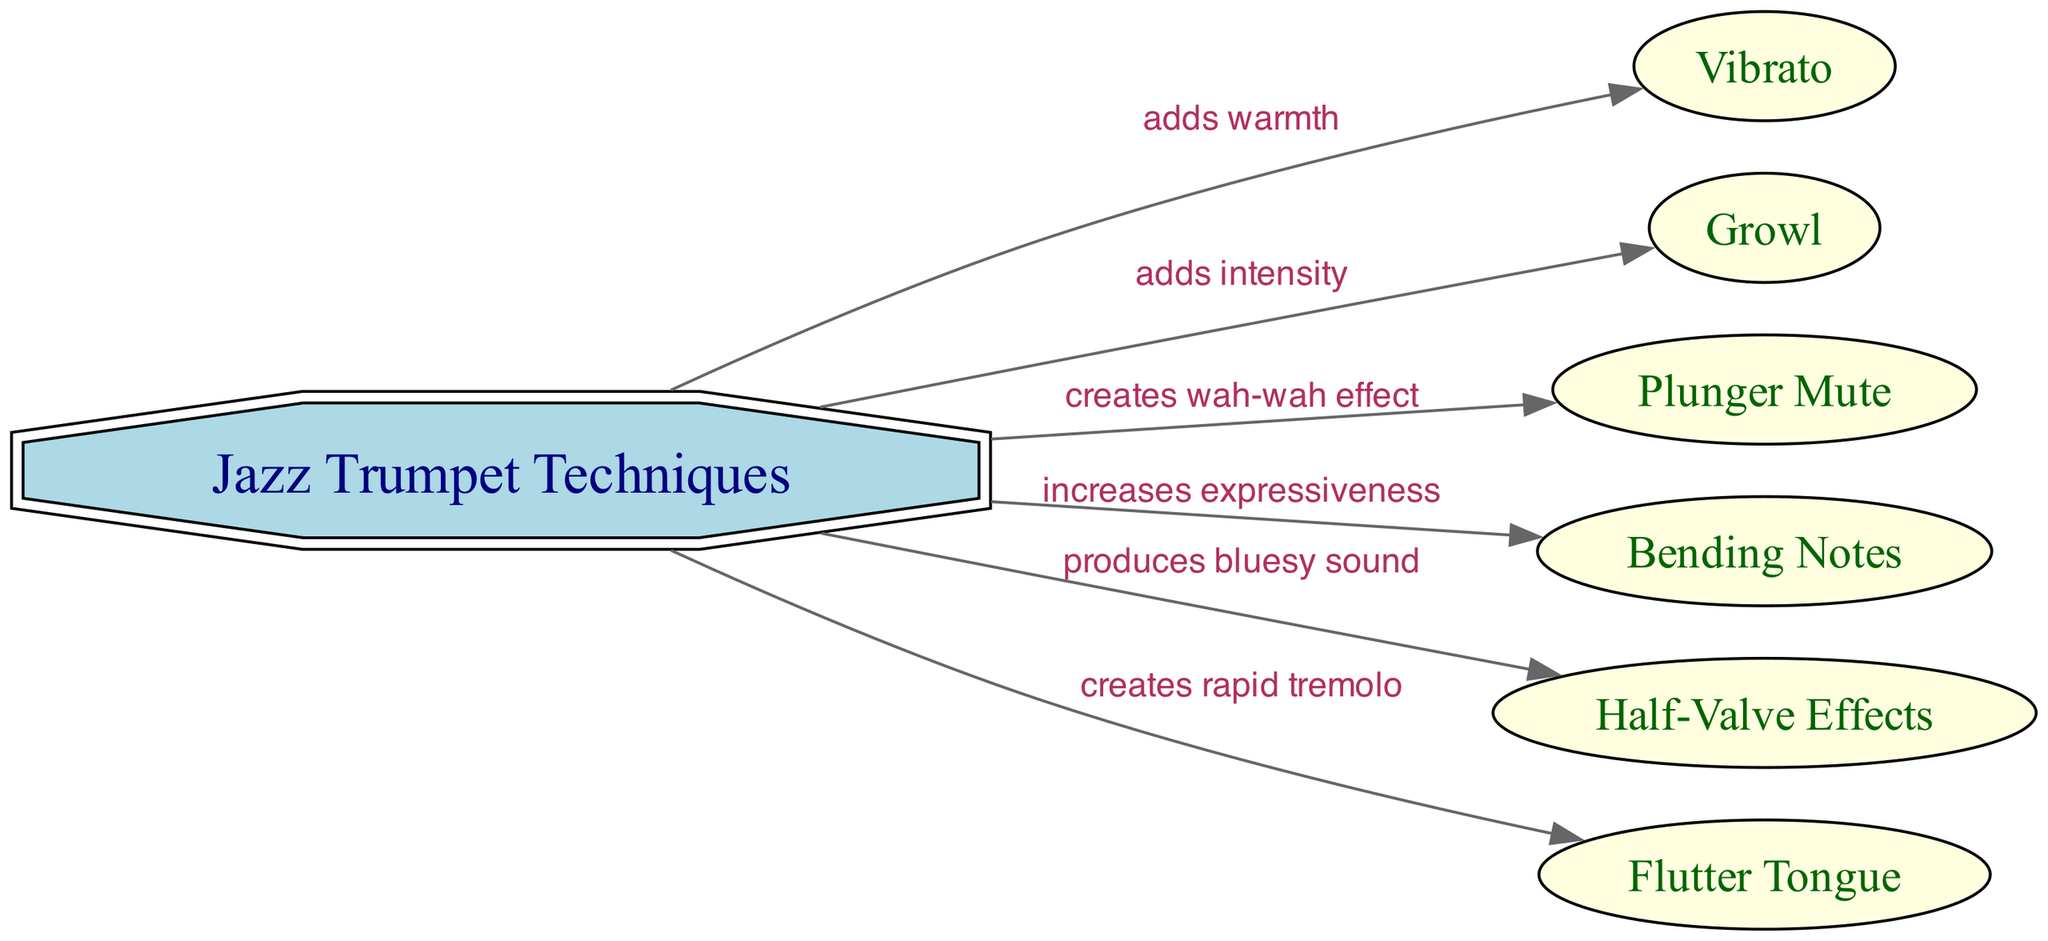What is the central topic of the diagram? The diagram centers around the topic of "Jazz Trumpet Techniques," which is the main node from which all other techniques stem. This is evident as it is the only node shaped like a double octagon, representing its primary importance.
Answer: Jazz Trumpet Techniques How many techniques are illustrated in the diagram? By counting the nodes connected to the main node "Jazz Trumpet Techniques," we see there are six techniques listed: Vibrato, Growl, Plunger Mute, Bending Notes, Half-Valve Effects, and Flutter Tongue.
Answer: 6 What effect does "Vibrato" have on sound? The edge from "Jazz Trumpet Techniques" to "Vibrato" clearly states that it "adds warmth." This indicates the sound effect attributed to the use of vibrato.
Answer: adds warmth Which technique is associated with creating a "wah-wah effect"? Upon examining the edges, it is noted that the "Plunger Mute" technique creates a "wah-wah effect," as specified in the connection from "Jazz Trumpet Techniques" to "Plunger Mute."
Answer: Plunger Mute What is the relationship between "Bending Notes" and expressiveness? The diagram shows an edge from "Jazz Trumpet Techniques" to "Bending Notes" which specifies that it "increases expressiveness." This indicates how this technique contributes to the expressive quality of the trumpet sound.
Answer: increases expressiveness How does "Half-Valve Effects" influence the sound quality? The diagram states that "Half-Valve Effects" produce a "bluesy sound," indicating its distinct tonal contribution to the music played on the trumpet. This connection is made directly from "Jazz Trumpet Techniques" to "Half-Valve Effects."
Answer: produces bluesy sound Which technique creates a rapid tremolo? The connection from "Jazz Trumpet Techniques" to "Flutter Tongue" reveals that this specific technique is responsible for creating a "rapid tremolo," defining its unique sound quality.
Answer: creates rapid tremolo What unique quality does the "Growl" technique add? Referring to the edge from "Jazz Trumpet Techniques" to "Growl," it is stated that this technique "adds intensity," denoting its significant impact on the emotional expression in trumpet performance.
Answer: adds intensity What shape represents "Vibrato" in the diagram? Observing the diagram, "Vibrato" is represented in an elliptical shape, contrasting its function as a specific technique in terms of visual representation.
Answer: ellipse How does the diagram depict the relationship between techniques and sound effects? The diagram visually connects various jazz trumpet techniques to their respective sound effects, illustrating how each technique influences the sound and overall expressiveness of trumpet music through labeled edges.
Answer: through labeled edges 